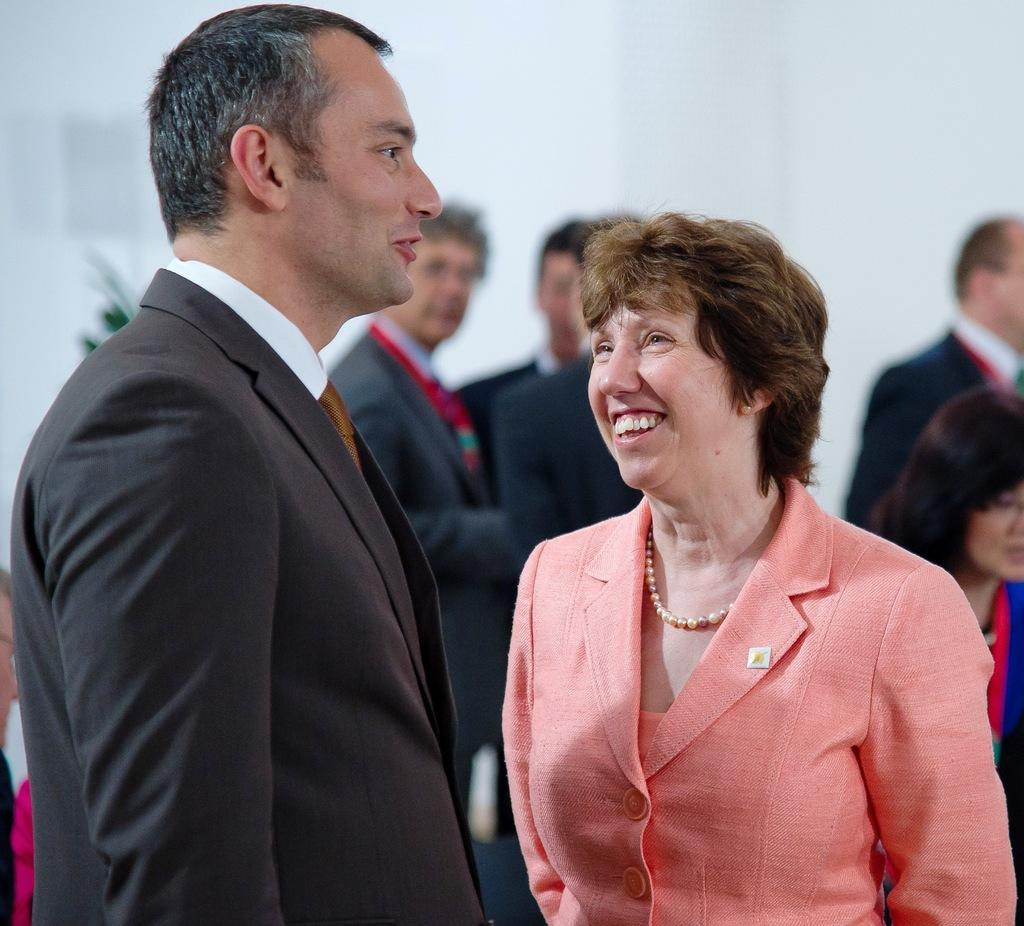Who is present in the image? There is a man and a woman in the image. What are the man and woman doing in the image? The man and woman are standing and smiling. Can you describe the people in the background of the image? There are people in the background of the image, but their actions or appearances are not specified. What is the man wearing in the image? The man is wearing a suit. What type of bee can be seen buzzing around the man's head in the image? There is no bee present in the image; it only features a man and a woman standing and smiling. What type of business are the man and woman discussing in the image? The image does not provide any information about a business or conversation between the man and woman. 